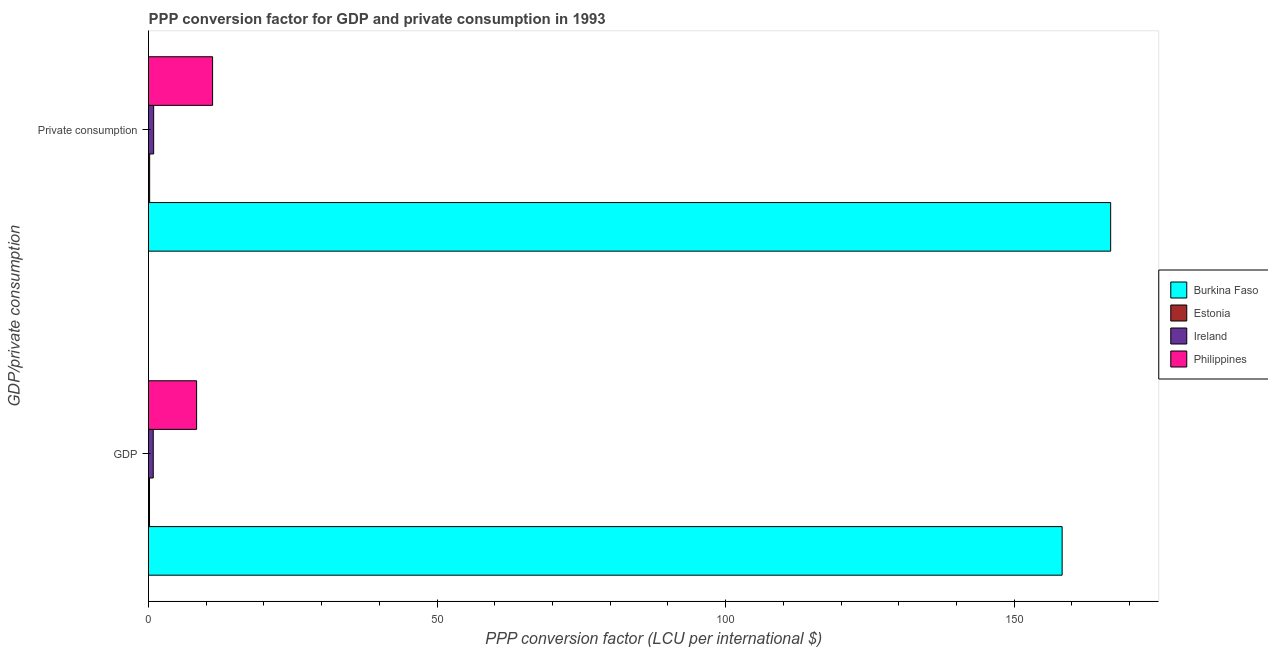How many different coloured bars are there?
Provide a succinct answer. 4. How many groups of bars are there?
Make the answer very short. 2. Are the number of bars per tick equal to the number of legend labels?
Your answer should be compact. Yes. How many bars are there on the 1st tick from the bottom?
Provide a short and direct response. 4. What is the label of the 1st group of bars from the top?
Your response must be concise.  Private consumption. What is the ppp conversion factor for gdp in Burkina Faso?
Keep it short and to the point. 158.29. Across all countries, what is the maximum ppp conversion factor for private consumption?
Provide a short and direct response. 166.7. Across all countries, what is the minimum ppp conversion factor for gdp?
Your answer should be compact. 0.17. In which country was the ppp conversion factor for private consumption maximum?
Your response must be concise. Burkina Faso. In which country was the ppp conversion factor for private consumption minimum?
Keep it short and to the point. Estonia. What is the total ppp conversion factor for gdp in the graph?
Ensure brevity in your answer.  167.62. What is the difference between the ppp conversion factor for private consumption in Estonia and that in Philippines?
Your response must be concise. -10.9. What is the difference between the ppp conversion factor for gdp in Ireland and the ppp conversion factor for private consumption in Burkina Faso?
Provide a short and direct response. -165.88. What is the average ppp conversion factor for private consumption per country?
Your response must be concise. 44.72. What is the difference between the ppp conversion factor for gdp and ppp conversion factor for private consumption in Burkina Faso?
Offer a very short reply. -8.41. What is the ratio of the ppp conversion factor for private consumption in Estonia to that in Philippines?
Ensure brevity in your answer.  0.02. In how many countries, is the ppp conversion factor for private consumption greater than the average ppp conversion factor for private consumption taken over all countries?
Your answer should be compact. 1. What does the 3rd bar from the top in  Private consumption represents?
Your answer should be very brief. Estonia. What does the 1st bar from the bottom in  Private consumption represents?
Your answer should be very brief. Burkina Faso. What is the difference between two consecutive major ticks on the X-axis?
Offer a terse response. 50. Are the values on the major ticks of X-axis written in scientific E-notation?
Give a very brief answer. No. Does the graph contain any zero values?
Keep it short and to the point. No. Does the graph contain grids?
Keep it short and to the point. No. Where does the legend appear in the graph?
Your answer should be very brief. Center right. How many legend labels are there?
Give a very brief answer. 4. How are the legend labels stacked?
Give a very brief answer. Vertical. What is the title of the graph?
Give a very brief answer. PPP conversion factor for GDP and private consumption in 1993. Does "Bosnia and Herzegovina" appear as one of the legend labels in the graph?
Provide a short and direct response. No. What is the label or title of the X-axis?
Your answer should be compact. PPP conversion factor (LCU per international $). What is the label or title of the Y-axis?
Make the answer very short. GDP/private consumption. What is the PPP conversion factor (LCU per international $) of Burkina Faso in GDP?
Your answer should be compact. 158.29. What is the PPP conversion factor (LCU per international $) of Estonia in GDP?
Keep it short and to the point. 0.17. What is the PPP conversion factor (LCU per international $) of Ireland in GDP?
Your answer should be very brief. 0.82. What is the PPP conversion factor (LCU per international $) of Philippines in GDP?
Your answer should be compact. 8.33. What is the PPP conversion factor (LCU per international $) of Burkina Faso in  Private consumption?
Keep it short and to the point. 166.7. What is the PPP conversion factor (LCU per international $) of Estonia in  Private consumption?
Provide a succinct answer. 0.2. What is the PPP conversion factor (LCU per international $) in Ireland in  Private consumption?
Your response must be concise. 0.89. What is the PPP conversion factor (LCU per international $) of Philippines in  Private consumption?
Offer a very short reply. 11.1. Across all GDP/private consumption, what is the maximum PPP conversion factor (LCU per international $) of Burkina Faso?
Make the answer very short. 166.7. Across all GDP/private consumption, what is the maximum PPP conversion factor (LCU per international $) of Estonia?
Your answer should be compact. 0.2. Across all GDP/private consumption, what is the maximum PPP conversion factor (LCU per international $) in Ireland?
Make the answer very short. 0.89. Across all GDP/private consumption, what is the maximum PPP conversion factor (LCU per international $) of Philippines?
Your response must be concise. 11.1. Across all GDP/private consumption, what is the minimum PPP conversion factor (LCU per international $) of Burkina Faso?
Provide a short and direct response. 158.29. Across all GDP/private consumption, what is the minimum PPP conversion factor (LCU per international $) in Estonia?
Your answer should be very brief. 0.17. Across all GDP/private consumption, what is the minimum PPP conversion factor (LCU per international $) in Ireland?
Ensure brevity in your answer.  0.82. Across all GDP/private consumption, what is the minimum PPP conversion factor (LCU per international $) in Philippines?
Make the answer very short. 8.33. What is the total PPP conversion factor (LCU per international $) in Burkina Faso in the graph?
Make the answer very short. 324.99. What is the total PPP conversion factor (LCU per international $) of Estonia in the graph?
Your response must be concise. 0.37. What is the total PPP conversion factor (LCU per international $) of Ireland in the graph?
Make the answer very short. 1.71. What is the total PPP conversion factor (LCU per international $) of Philippines in the graph?
Ensure brevity in your answer.  19.43. What is the difference between the PPP conversion factor (LCU per international $) in Burkina Faso in GDP and that in  Private consumption?
Your response must be concise. -8.41. What is the difference between the PPP conversion factor (LCU per international $) of Estonia in GDP and that in  Private consumption?
Offer a very short reply. -0.02. What is the difference between the PPP conversion factor (LCU per international $) of Ireland in GDP and that in  Private consumption?
Your answer should be compact. -0.07. What is the difference between the PPP conversion factor (LCU per international $) of Philippines in GDP and that in  Private consumption?
Your answer should be compact. -2.77. What is the difference between the PPP conversion factor (LCU per international $) in Burkina Faso in GDP and the PPP conversion factor (LCU per international $) in Estonia in  Private consumption?
Your response must be concise. 158.1. What is the difference between the PPP conversion factor (LCU per international $) of Burkina Faso in GDP and the PPP conversion factor (LCU per international $) of Ireland in  Private consumption?
Give a very brief answer. 157.4. What is the difference between the PPP conversion factor (LCU per international $) in Burkina Faso in GDP and the PPP conversion factor (LCU per international $) in Philippines in  Private consumption?
Make the answer very short. 147.19. What is the difference between the PPP conversion factor (LCU per international $) of Estonia in GDP and the PPP conversion factor (LCU per international $) of Ireland in  Private consumption?
Your answer should be compact. -0.72. What is the difference between the PPP conversion factor (LCU per international $) in Estonia in GDP and the PPP conversion factor (LCU per international $) in Philippines in  Private consumption?
Offer a terse response. -10.93. What is the difference between the PPP conversion factor (LCU per international $) of Ireland in GDP and the PPP conversion factor (LCU per international $) of Philippines in  Private consumption?
Your answer should be very brief. -10.28. What is the average PPP conversion factor (LCU per international $) of Burkina Faso per GDP/private consumption?
Give a very brief answer. 162.5. What is the average PPP conversion factor (LCU per international $) in Estonia per GDP/private consumption?
Ensure brevity in your answer.  0.18. What is the average PPP conversion factor (LCU per international $) of Ireland per GDP/private consumption?
Give a very brief answer. 0.85. What is the average PPP conversion factor (LCU per international $) in Philippines per GDP/private consumption?
Your answer should be compact. 9.72. What is the difference between the PPP conversion factor (LCU per international $) in Burkina Faso and PPP conversion factor (LCU per international $) in Estonia in GDP?
Offer a very short reply. 158.12. What is the difference between the PPP conversion factor (LCU per international $) of Burkina Faso and PPP conversion factor (LCU per international $) of Ireland in GDP?
Keep it short and to the point. 157.47. What is the difference between the PPP conversion factor (LCU per international $) in Burkina Faso and PPP conversion factor (LCU per international $) in Philippines in GDP?
Offer a very short reply. 149.96. What is the difference between the PPP conversion factor (LCU per international $) in Estonia and PPP conversion factor (LCU per international $) in Ireland in GDP?
Your response must be concise. -0.65. What is the difference between the PPP conversion factor (LCU per international $) in Estonia and PPP conversion factor (LCU per international $) in Philippines in GDP?
Your answer should be compact. -8.16. What is the difference between the PPP conversion factor (LCU per international $) in Ireland and PPP conversion factor (LCU per international $) in Philippines in GDP?
Offer a very short reply. -7.51. What is the difference between the PPP conversion factor (LCU per international $) in Burkina Faso and PPP conversion factor (LCU per international $) in Estonia in  Private consumption?
Your answer should be very brief. 166.5. What is the difference between the PPP conversion factor (LCU per international $) of Burkina Faso and PPP conversion factor (LCU per international $) of Ireland in  Private consumption?
Provide a succinct answer. 165.81. What is the difference between the PPP conversion factor (LCU per international $) of Burkina Faso and PPP conversion factor (LCU per international $) of Philippines in  Private consumption?
Give a very brief answer. 155.6. What is the difference between the PPP conversion factor (LCU per international $) of Estonia and PPP conversion factor (LCU per international $) of Ireland in  Private consumption?
Offer a very short reply. -0.69. What is the difference between the PPP conversion factor (LCU per international $) of Estonia and PPP conversion factor (LCU per international $) of Philippines in  Private consumption?
Make the answer very short. -10.9. What is the difference between the PPP conversion factor (LCU per international $) of Ireland and PPP conversion factor (LCU per international $) of Philippines in  Private consumption?
Your response must be concise. -10.21. What is the ratio of the PPP conversion factor (LCU per international $) in Burkina Faso in GDP to that in  Private consumption?
Your answer should be compact. 0.95. What is the ratio of the PPP conversion factor (LCU per international $) of Estonia in GDP to that in  Private consumption?
Your response must be concise. 0.88. What is the ratio of the PPP conversion factor (LCU per international $) of Ireland in GDP to that in  Private consumption?
Give a very brief answer. 0.92. What is the ratio of the PPP conversion factor (LCU per international $) of Philippines in GDP to that in  Private consumption?
Your response must be concise. 0.75. What is the difference between the highest and the second highest PPP conversion factor (LCU per international $) of Burkina Faso?
Offer a terse response. 8.41. What is the difference between the highest and the second highest PPP conversion factor (LCU per international $) of Estonia?
Your answer should be compact. 0.02. What is the difference between the highest and the second highest PPP conversion factor (LCU per international $) in Ireland?
Offer a terse response. 0.07. What is the difference between the highest and the second highest PPP conversion factor (LCU per international $) of Philippines?
Offer a very short reply. 2.77. What is the difference between the highest and the lowest PPP conversion factor (LCU per international $) in Burkina Faso?
Keep it short and to the point. 8.41. What is the difference between the highest and the lowest PPP conversion factor (LCU per international $) in Estonia?
Keep it short and to the point. 0.02. What is the difference between the highest and the lowest PPP conversion factor (LCU per international $) of Ireland?
Keep it short and to the point. 0.07. What is the difference between the highest and the lowest PPP conversion factor (LCU per international $) in Philippines?
Give a very brief answer. 2.77. 